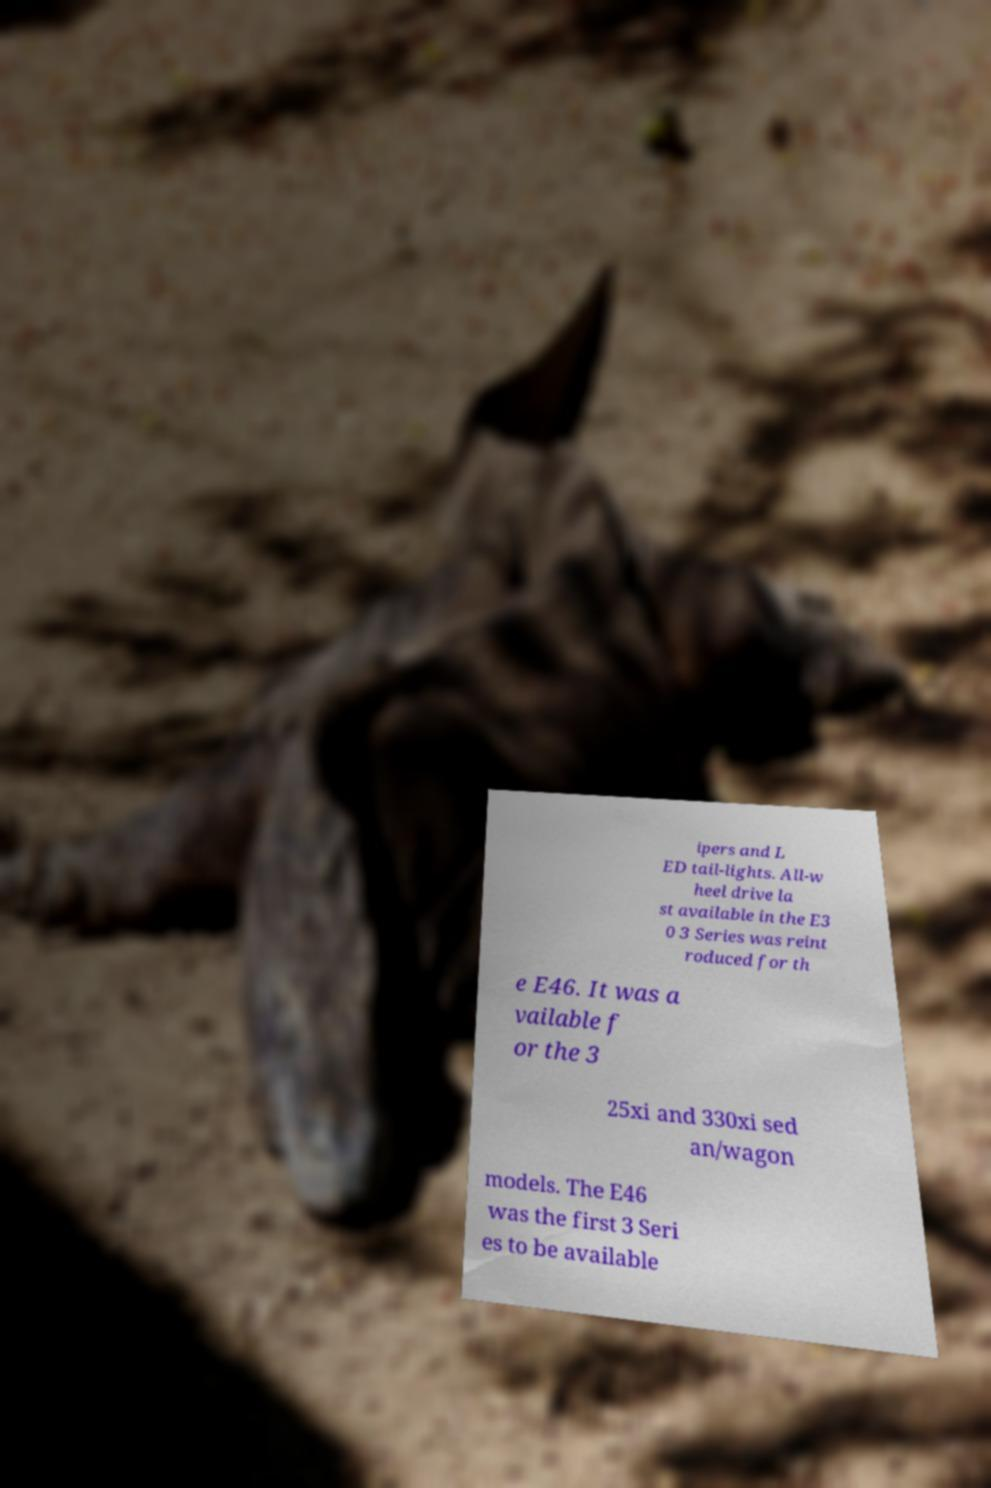For documentation purposes, I need the text within this image transcribed. Could you provide that? ipers and L ED tail-lights. All-w heel drive la st available in the E3 0 3 Series was reint roduced for th e E46. It was a vailable f or the 3 25xi and 330xi sed an/wagon models. The E46 was the first 3 Seri es to be available 